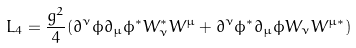<formula> <loc_0><loc_0><loc_500><loc_500>L _ { 4 } = \frac { g ^ { 2 } } { 4 } ( \partial ^ { \nu } \phi \partial _ { \mu } \phi ^ { \ast } W _ { \nu } ^ { \ast } W ^ { \mu } + \partial ^ { \nu } \phi ^ { \ast } \partial _ { \mu } \phi W _ { \nu } W ^ { \mu \ast } )</formula> 